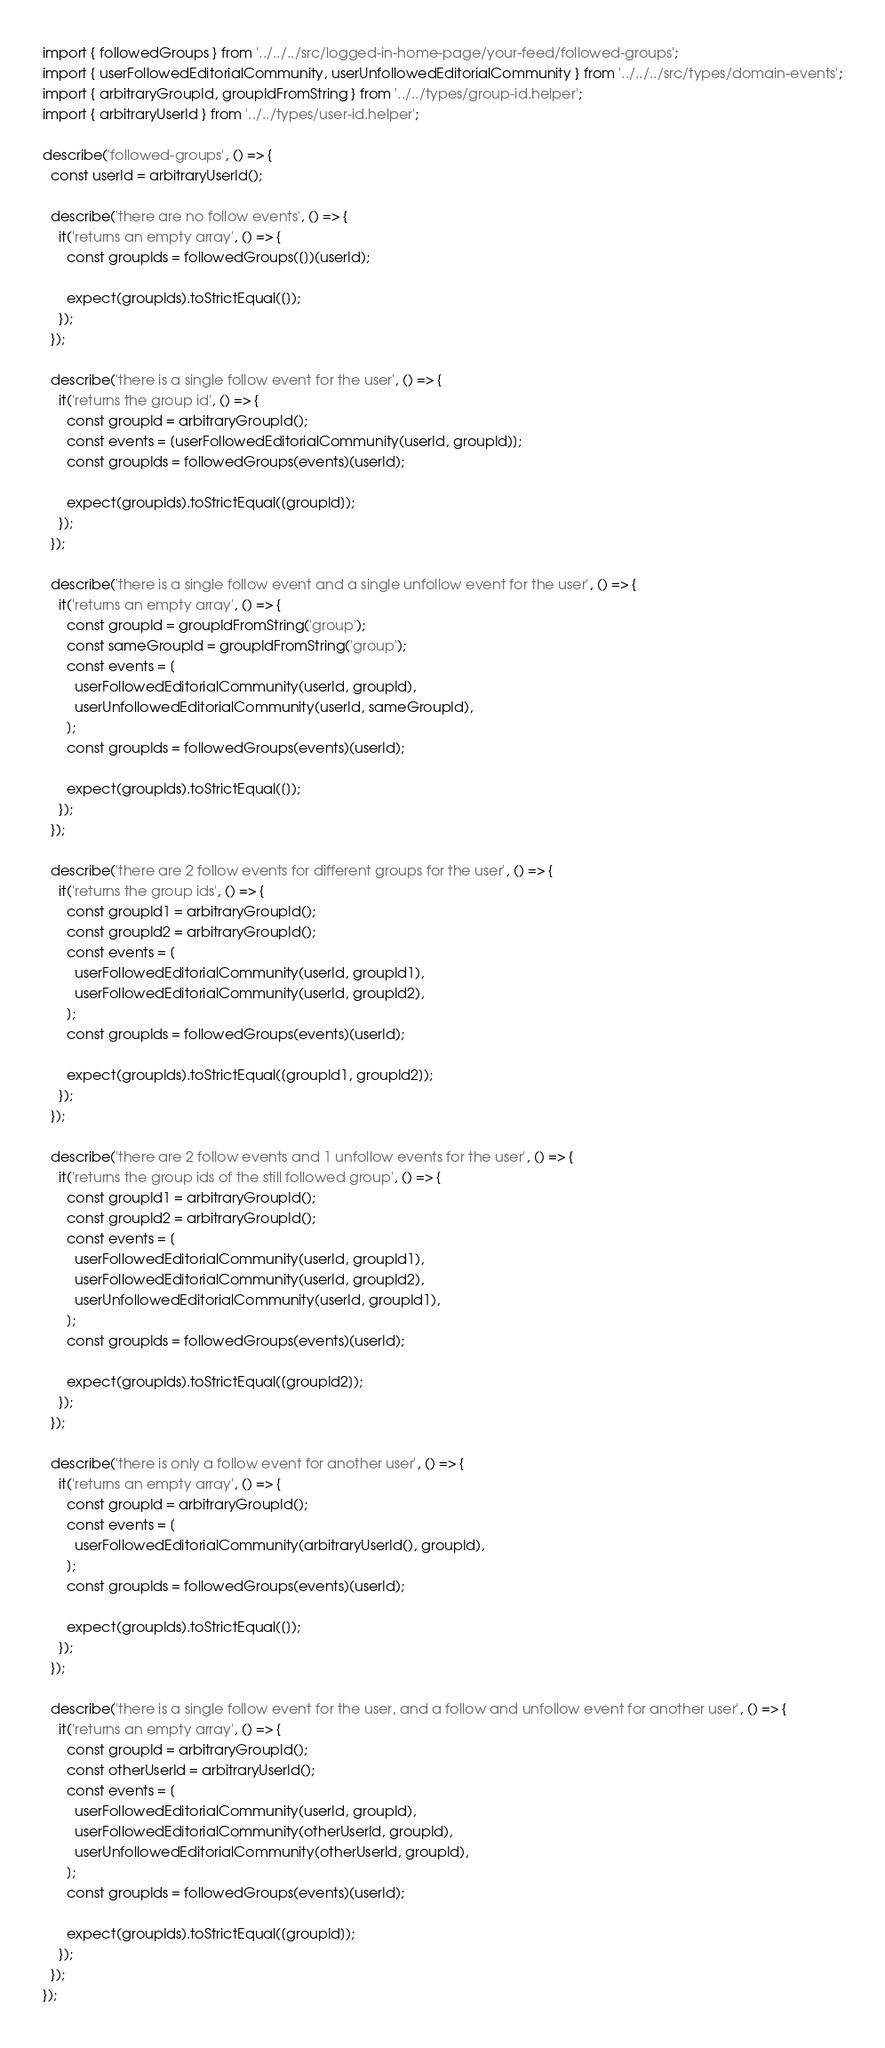Convert code to text. <code><loc_0><loc_0><loc_500><loc_500><_TypeScript_>import { followedGroups } from '../../../src/logged-in-home-page/your-feed/followed-groups';
import { userFollowedEditorialCommunity, userUnfollowedEditorialCommunity } from '../../../src/types/domain-events';
import { arbitraryGroupId, groupIdFromString } from '../../types/group-id.helper';
import { arbitraryUserId } from '../../types/user-id.helper';

describe('followed-groups', () => {
  const userId = arbitraryUserId();

  describe('there are no follow events', () => {
    it('returns an empty array', () => {
      const groupIds = followedGroups([])(userId);

      expect(groupIds).toStrictEqual([]);
    });
  });

  describe('there is a single follow event for the user', () => {
    it('returns the group id', () => {
      const groupId = arbitraryGroupId();
      const events = [userFollowedEditorialCommunity(userId, groupId)];
      const groupIds = followedGroups(events)(userId);

      expect(groupIds).toStrictEqual([groupId]);
    });
  });

  describe('there is a single follow event and a single unfollow event for the user', () => {
    it('returns an empty array', () => {
      const groupId = groupIdFromString('group');
      const sameGroupId = groupIdFromString('group');
      const events = [
        userFollowedEditorialCommunity(userId, groupId),
        userUnfollowedEditorialCommunity(userId, sameGroupId),
      ];
      const groupIds = followedGroups(events)(userId);

      expect(groupIds).toStrictEqual([]);
    });
  });

  describe('there are 2 follow events for different groups for the user', () => {
    it('returns the group ids', () => {
      const groupId1 = arbitraryGroupId();
      const groupId2 = arbitraryGroupId();
      const events = [
        userFollowedEditorialCommunity(userId, groupId1),
        userFollowedEditorialCommunity(userId, groupId2),
      ];
      const groupIds = followedGroups(events)(userId);

      expect(groupIds).toStrictEqual([groupId1, groupId2]);
    });
  });

  describe('there are 2 follow events and 1 unfollow events for the user', () => {
    it('returns the group ids of the still followed group', () => {
      const groupId1 = arbitraryGroupId();
      const groupId2 = arbitraryGroupId();
      const events = [
        userFollowedEditorialCommunity(userId, groupId1),
        userFollowedEditorialCommunity(userId, groupId2),
        userUnfollowedEditorialCommunity(userId, groupId1),
      ];
      const groupIds = followedGroups(events)(userId);

      expect(groupIds).toStrictEqual([groupId2]);
    });
  });

  describe('there is only a follow event for another user', () => {
    it('returns an empty array', () => {
      const groupId = arbitraryGroupId();
      const events = [
        userFollowedEditorialCommunity(arbitraryUserId(), groupId),
      ];
      const groupIds = followedGroups(events)(userId);

      expect(groupIds).toStrictEqual([]);
    });
  });

  describe('there is a single follow event for the user, and a follow and unfollow event for another user', () => {
    it('returns an empty array', () => {
      const groupId = arbitraryGroupId();
      const otherUserId = arbitraryUserId();
      const events = [
        userFollowedEditorialCommunity(userId, groupId),
        userFollowedEditorialCommunity(otherUserId, groupId),
        userUnfollowedEditorialCommunity(otherUserId, groupId),
      ];
      const groupIds = followedGroups(events)(userId);

      expect(groupIds).toStrictEqual([groupId]);
    });
  });
});
</code> 